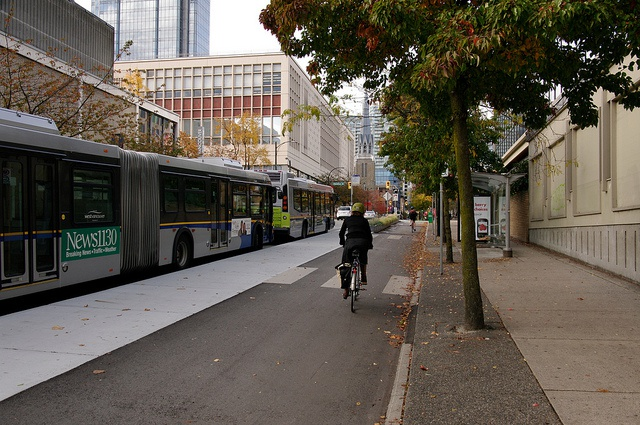Describe the objects in this image and their specific colors. I can see bus in black, gray, darkgray, and darkgreen tones, bus in black, gray, darkgray, and olive tones, people in black, gray, olive, and darkgray tones, bicycle in black, gray, darkgray, and maroon tones, and people in black, gray, and maroon tones in this image. 